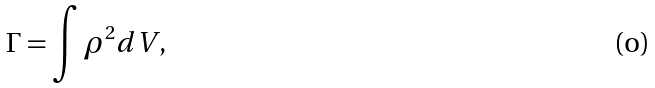Convert formula to latex. <formula><loc_0><loc_0><loc_500><loc_500>\Gamma = \int \rho ^ { 2 } d V ,</formula> 